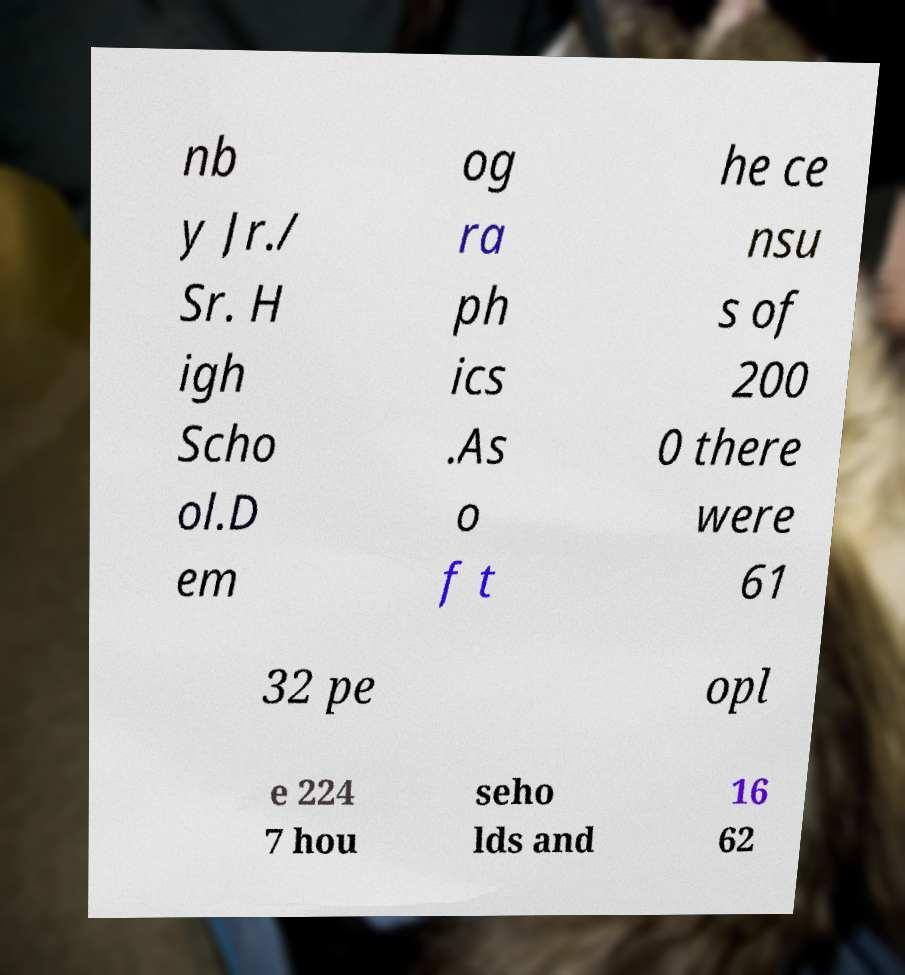Please identify and transcribe the text found in this image. nb y Jr./ Sr. H igh Scho ol.D em og ra ph ics .As o f t he ce nsu s of 200 0 there were 61 32 pe opl e 224 7 hou seho lds and 16 62 